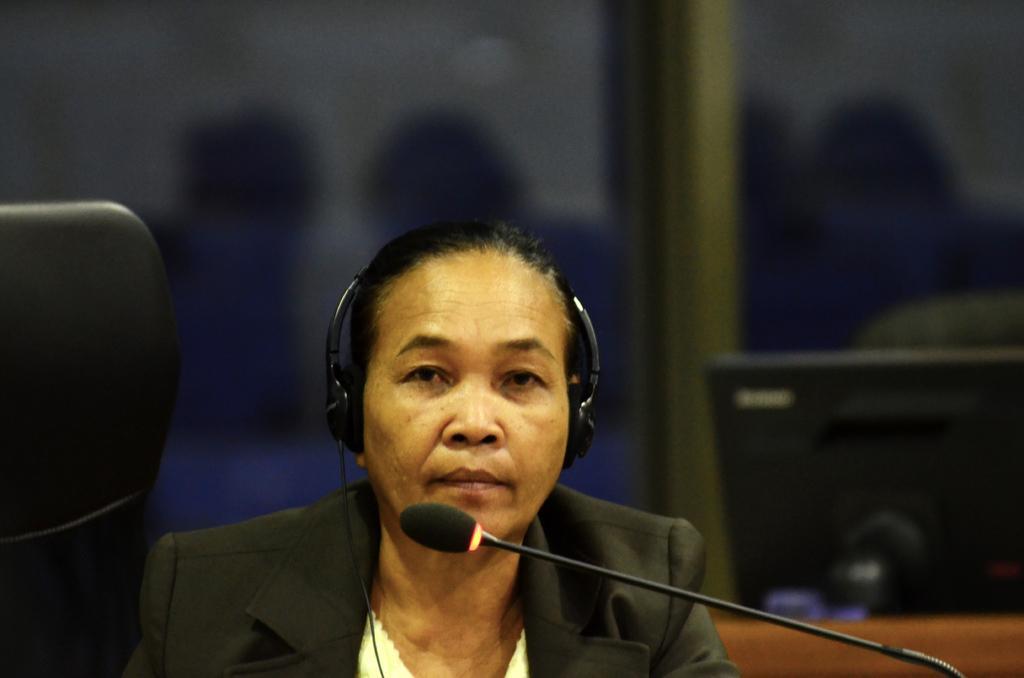Can you describe this image briefly? In the center of this picture we can see a person wearing headphones, blazer and seems to be sitting on the chair. On the right we can see a microphone and an electronic device. In the background we can see some other objects. 